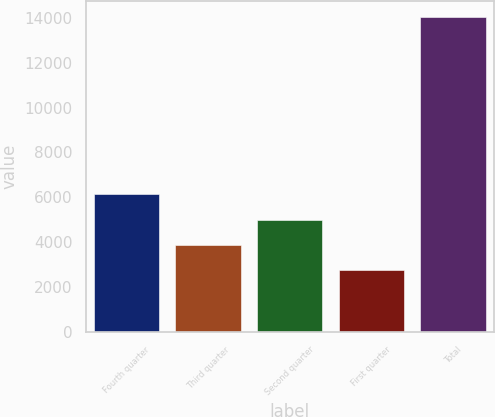Convert chart to OTSL. <chart><loc_0><loc_0><loc_500><loc_500><bar_chart><fcel>Fourth quarter<fcel>Third quarter<fcel>Second quarter<fcel>First quarter<fcel>Total<nl><fcel>6139.2<fcel>3874.4<fcel>5006.8<fcel>2742<fcel>14066<nl></chart> 